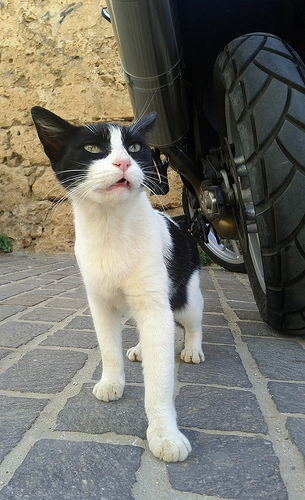<image>
Can you confirm if the kitten is to the left of the tire? Yes. From this viewpoint, the kitten is positioned to the left side relative to the tire. 